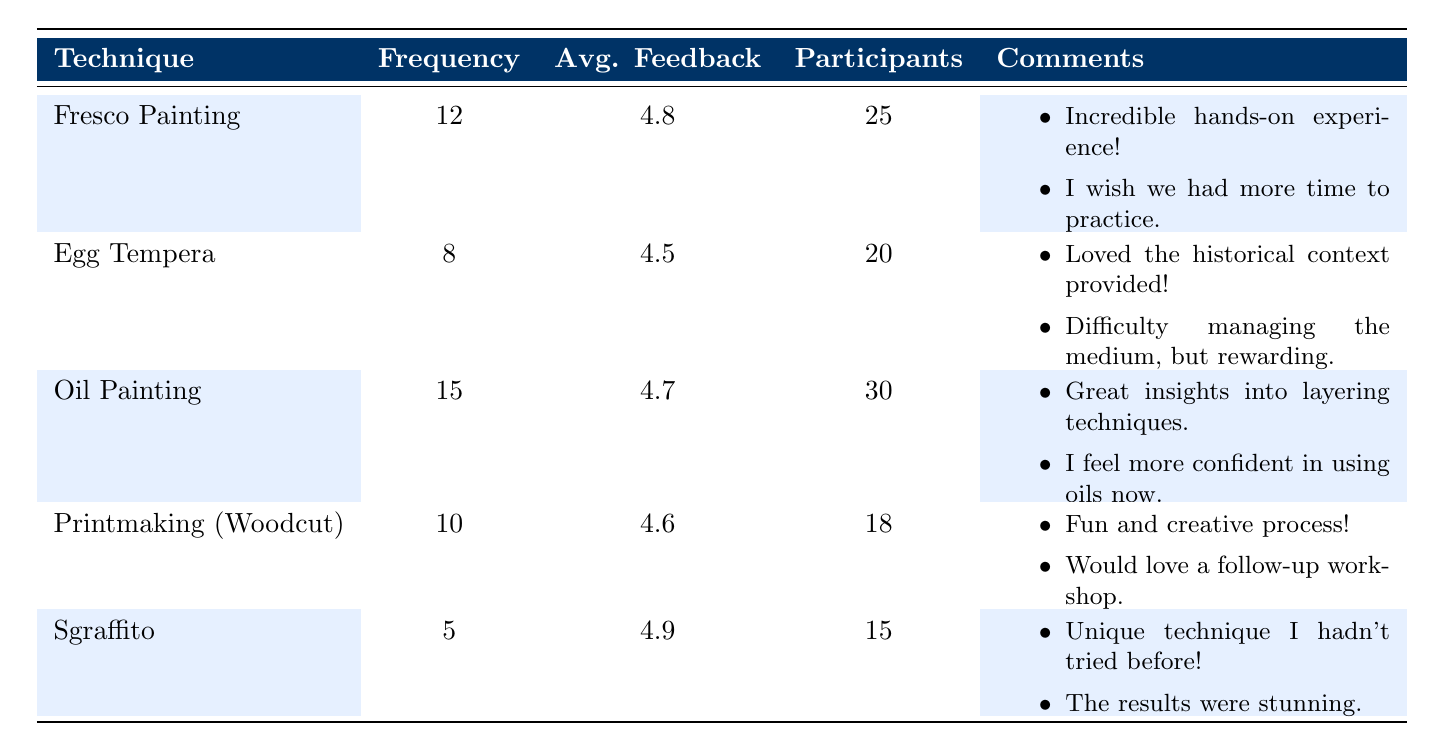What technique had the highest average feedback score? By reviewing the average feedback scores provided for each technique, we see that Sgraffito has an average score of 4.9, which is higher than Fresco Painting's 4.8, Egg Tempera's 4.5, Oil Painting's 4.7, and Printmaking's 4.6.
Answer: Sgraffito How many participants attended the Oil Painting workshop? The table lists Oil Painting as having 30 participants, which is directly stated.
Answer: 30 What is the total frequency of all workshops combined? To find the total frequency, we sum the frequency values: 12 (Fresco Painting) + 8 (Egg Tempera) + 15 (Oil Painting) + 10 (Printmaking) + 5 (Sgraffito) = 50. Thus, the total frequency is 50.
Answer: 50 Did the Printmaking workshop receive an average feedback score of 5 or higher? Printmaking (Woodcut) has an average feedback score of 4.6, which is below 5. Therefore, the answer is no.
Answer: No Which technique had the lowest frequency of workshops offered? Examining the frequency column, we find Sgraffito with a frequency of 5, which is lower than all other techniques' frequencies (Fresco Painting 12, Egg Tempera 8, Oil Painting 15, and Printmaking 10).
Answer: Sgraffito What is the average number of participants across all workshops? To find the average number of participants, we add the participant counts: 25 (Fresco) + 20 (Egg Tempera) + 30 (Oil) + 18 (Printmaking) + 15 (Sgraffito) = 108 participants. Then, we divide by the number of workshops (5): 108/5 = 21.6, yielding an average of about 22 participants.
Answer: 22 How many workshops had an average feedback score above 4.7? The techniques with average scores above 4.7 are Fresco Painting (4.8) and Sgraffito (4.9). Therefore, two workshops meet this criterion.
Answer: 2 What comments were given for the Egg Tempera workshop? The comments listed for the Egg Tempera workshop include 1) "Loved the historical context provided!" and 2) "Difficulty managing the medium, but rewarding." These comments can be referenced directly from the table entry.
Answer: Loved the historical context provided, Difficulty managing the medium, but rewarding 